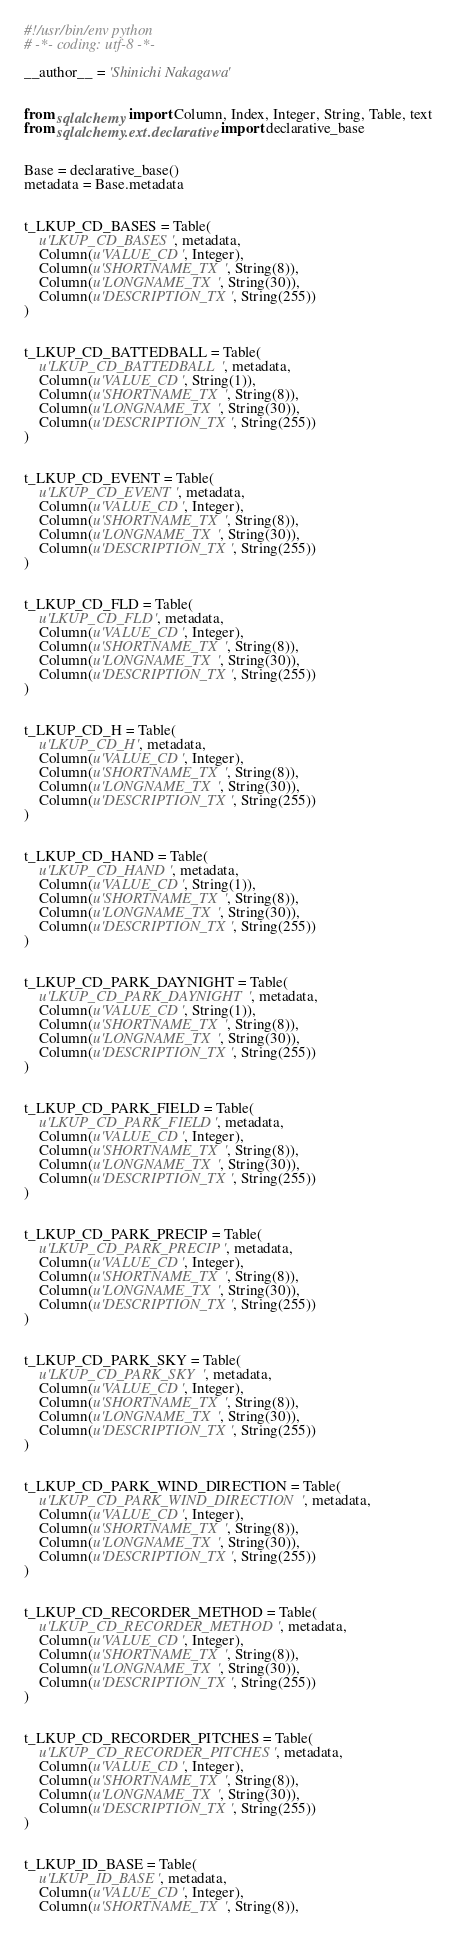<code> <loc_0><loc_0><loc_500><loc_500><_Python_>#!/usr/bin/env python
# -*- coding: utf-8 -*-

__author__ = 'Shinichi Nakagawa'


from sqlalchemy import Column, Index, Integer, String, Table, text
from sqlalchemy.ext.declarative import declarative_base


Base = declarative_base()
metadata = Base.metadata


t_LKUP_CD_BASES = Table(
    u'LKUP_CD_BASES', metadata,
    Column(u'VALUE_CD', Integer),
    Column(u'SHORTNAME_TX', String(8)),
    Column(u'LONGNAME_TX', String(30)),
    Column(u'DESCRIPTION_TX', String(255))
)


t_LKUP_CD_BATTEDBALL = Table(
    u'LKUP_CD_BATTEDBALL', metadata,
    Column(u'VALUE_CD', String(1)),
    Column(u'SHORTNAME_TX', String(8)),
    Column(u'LONGNAME_TX', String(30)),
    Column(u'DESCRIPTION_TX', String(255))
)


t_LKUP_CD_EVENT = Table(
    u'LKUP_CD_EVENT', metadata,
    Column(u'VALUE_CD', Integer),
    Column(u'SHORTNAME_TX', String(8)),
    Column(u'LONGNAME_TX', String(30)),
    Column(u'DESCRIPTION_TX', String(255))
)


t_LKUP_CD_FLD = Table(
    u'LKUP_CD_FLD', metadata,
    Column(u'VALUE_CD', Integer),
    Column(u'SHORTNAME_TX', String(8)),
    Column(u'LONGNAME_TX', String(30)),
    Column(u'DESCRIPTION_TX', String(255))
)


t_LKUP_CD_H = Table(
    u'LKUP_CD_H', metadata,
    Column(u'VALUE_CD', Integer),
    Column(u'SHORTNAME_TX', String(8)),
    Column(u'LONGNAME_TX', String(30)),
    Column(u'DESCRIPTION_TX', String(255))
)


t_LKUP_CD_HAND = Table(
    u'LKUP_CD_HAND', metadata,
    Column(u'VALUE_CD', String(1)),
    Column(u'SHORTNAME_TX', String(8)),
    Column(u'LONGNAME_TX', String(30)),
    Column(u'DESCRIPTION_TX', String(255))
)


t_LKUP_CD_PARK_DAYNIGHT = Table(
    u'LKUP_CD_PARK_DAYNIGHT', metadata,
    Column(u'VALUE_CD', String(1)),
    Column(u'SHORTNAME_TX', String(8)),
    Column(u'LONGNAME_TX', String(30)),
    Column(u'DESCRIPTION_TX', String(255))
)


t_LKUP_CD_PARK_FIELD = Table(
    u'LKUP_CD_PARK_FIELD', metadata,
    Column(u'VALUE_CD', Integer),
    Column(u'SHORTNAME_TX', String(8)),
    Column(u'LONGNAME_TX', String(30)),
    Column(u'DESCRIPTION_TX', String(255))
)


t_LKUP_CD_PARK_PRECIP = Table(
    u'LKUP_CD_PARK_PRECIP', metadata,
    Column(u'VALUE_CD', Integer),
    Column(u'SHORTNAME_TX', String(8)),
    Column(u'LONGNAME_TX', String(30)),
    Column(u'DESCRIPTION_TX', String(255))
)


t_LKUP_CD_PARK_SKY = Table(
    u'LKUP_CD_PARK_SKY', metadata,
    Column(u'VALUE_CD', Integer),
    Column(u'SHORTNAME_TX', String(8)),
    Column(u'LONGNAME_TX', String(30)),
    Column(u'DESCRIPTION_TX', String(255))
)


t_LKUP_CD_PARK_WIND_DIRECTION = Table(
    u'LKUP_CD_PARK_WIND_DIRECTION', metadata,
    Column(u'VALUE_CD', Integer),
    Column(u'SHORTNAME_TX', String(8)),
    Column(u'LONGNAME_TX', String(30)),
    Column(u'DESCRIPTION_TX', String(255))
)


t_LKUP_CD_RECORDER_METHOD = Table(
    u'LKUP_CD_RECORDER_METHOD', metadata,
    Column(u'VALUE_CD', Integer),
    Column(u'SHORTNAME_TX', String(8)),
    Column(u'LONGNAME_TX', String(30)),
    Column(u'DESCRIPTION_TX', String(255))
)


t_LKUP_CD_RECORDER_PITCHES = Table(
    u'LKUP_CD_RECORDER_PITCHES', metadata,
    Column(u'VALUE_CD', Integer),
    Column(u'SHORTNAME_TX', String(8)),
    Column(u'LONGNAME_TX', String(30)),
    Column(u'DESCRIPTION_TX', String(255))
)


t_LKUP_ID_BASE = Table(
    u'LKUP_ID_BASE', metadata,
    Column(u'VALUE_CD', Integer),
    Column(u'SHORTNAME_TX', String(8)),</code> 